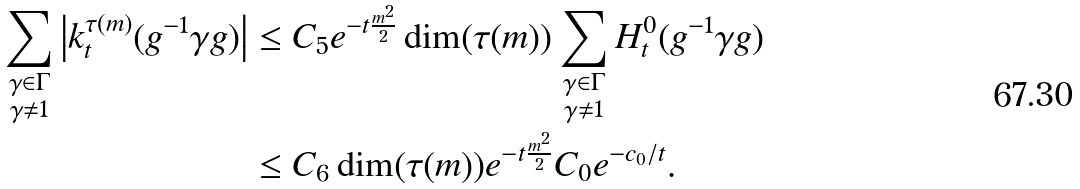<formula> <loc_0><loc_0><loc_500><loc_500>\sum _ { \substack { \gamma \in \Gamma \\ \gamma \neq 1 } } \left | k _ { t } ^ { \tau ( m ) } ( g ^ { - 1 } \gamma g ) \right | & \leq C _ { 5 } e ^ { - t \frac { m ^ { 2 } } { 2 } } \dim ( \tau ( m ) ) \sum _ { \substack { \gamma \in \Gamma \\ \gamma \neq 1 } } H _ { t } ^ { 0 } ( g ^ { - 1 } \gamma g ) \\ & \leq C _ { 6 } \dim ( \tau ( m ) ) e ^ { - t \frac { m ^ { 2 } } { 2 } } C _ { 0 } e ^ { - c _ { 0 } / t } .</formula> 